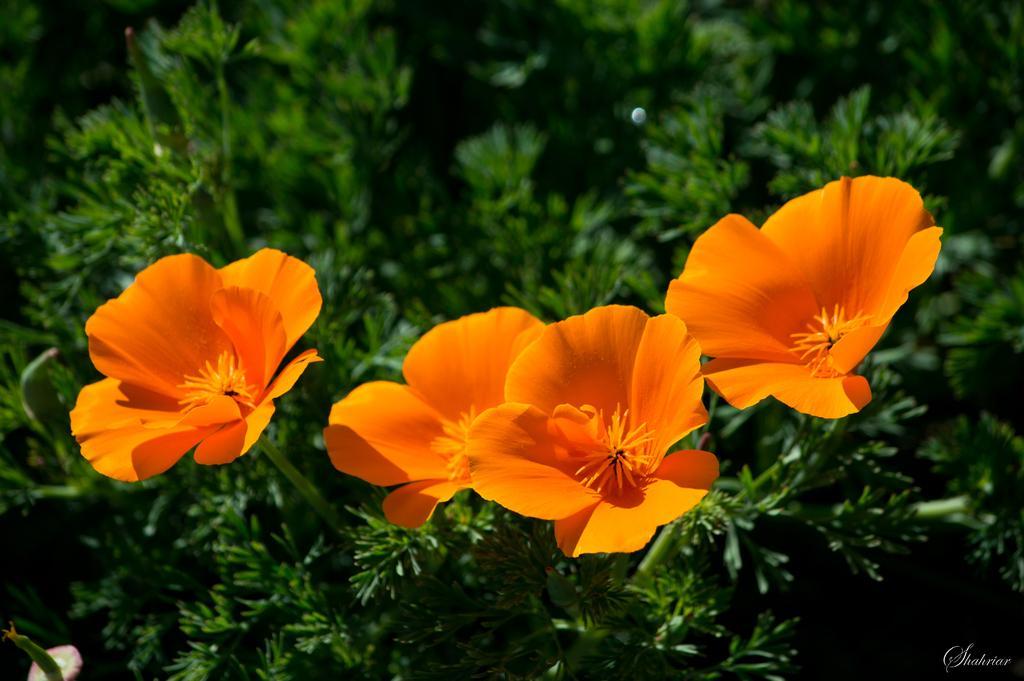Please provide a concise description of this image. In this image there are flower plants, in the bottom right there is text. 